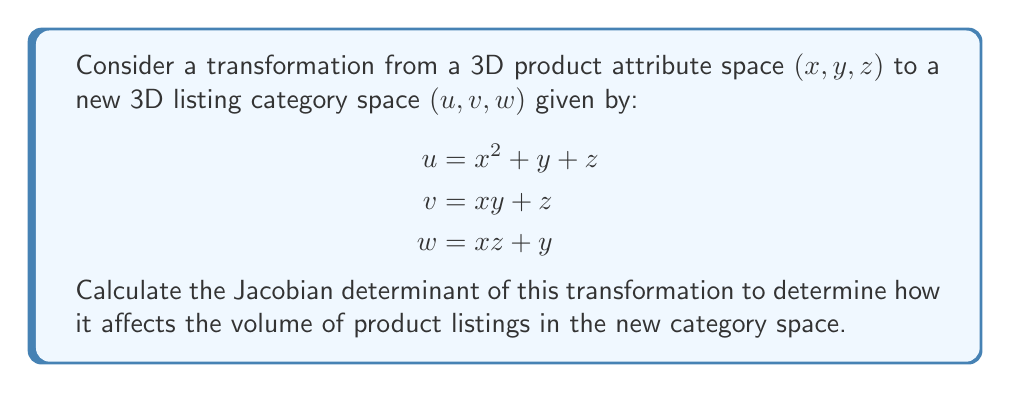Help me with this question. To calculate the Jacobian determinant, we need to follow these steps:

1. Form the Jacobian matrix by taking partial derivatives of each new coordinate $(u, v, w)$ with respect to each original coordinate $(x, y, z)$:

$$J = \begin{bmatrix}
\frac{\partial u}{\partial x} & \frac{\partial u}{\partial y} & \frac{\partial u}{\partial z} \\
\frac{\partial v}{\partial x} & \frac{\partial v}{\partial y} & \frac{\partial v}{\partial z} \\
\frac{\partial w}{\partial x} & \frac{\partial w}{\partial y} & \frac{\partial w}{\partial z}
\end{bmatrix}$$

2. Calculate each partial derivative:

$$\begin{aligned}
\frac{\partial u}{\partial x} = 2x, \quad \frac{\partial u}{\partial y} = 1, \quad \frac{\partial u}{\partial z} = 1 \\
\frac{\partial v}{\partial x} = y, \quad \frac{\partial v}{\partial y} = x, \quad \frac{\partial v}{\partial z} = 1 \\
\frac{\partial w}{\partial x} = z, \quad \frac{\partial w}{\partial y} = 1, \quad \frac{\partial w}{\partial z} = x
\end{aligned}$$

3. Substitute these values into the Jacobian matrix:

$$J = \begin{bmatrix}
2x & 1 & 1 \\
y & x & 1 \\
z & 1 & x
\end{bmatrix}$$

4. Calculate the determinant of the Jacobian matrix:

$$\begin{aligned}
\det(J) &= 2x \cdot (x \cdot x - 1 \cdot 1) - 1 \cdot (y \cdot x - z \cdot 1) + 1 \cdot (y \cdot 1 - z \cdot x) \\
&= 2x(x^2 - 1) - (xy - z) + (y - zx) \\
&= 2x^3 - 2x - xy + z + y - zx \\
&= 2x^3 - xy - zx - 2x + y + z
\end{aligned}$$

This Jacobian determinant represents the local scaling factor of volumes under the transformation.
Answer: $2x^3 - xy - zx - 2x + y + z$ 